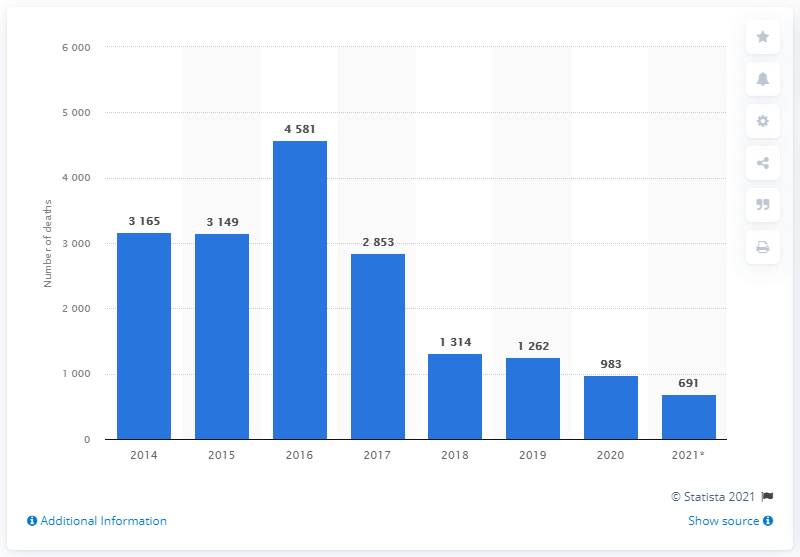Draw attention to some important aspects in this diagram. According to recent data, 691 individuals lost their lives while attempting to cross the Central Mediterranean route between January and June 2021. In 2016, a total of 4,581 migrants died in the Central Mediterranean Sea. In 2016, the number of deaths on the Central Mediterranean Route peaked. 